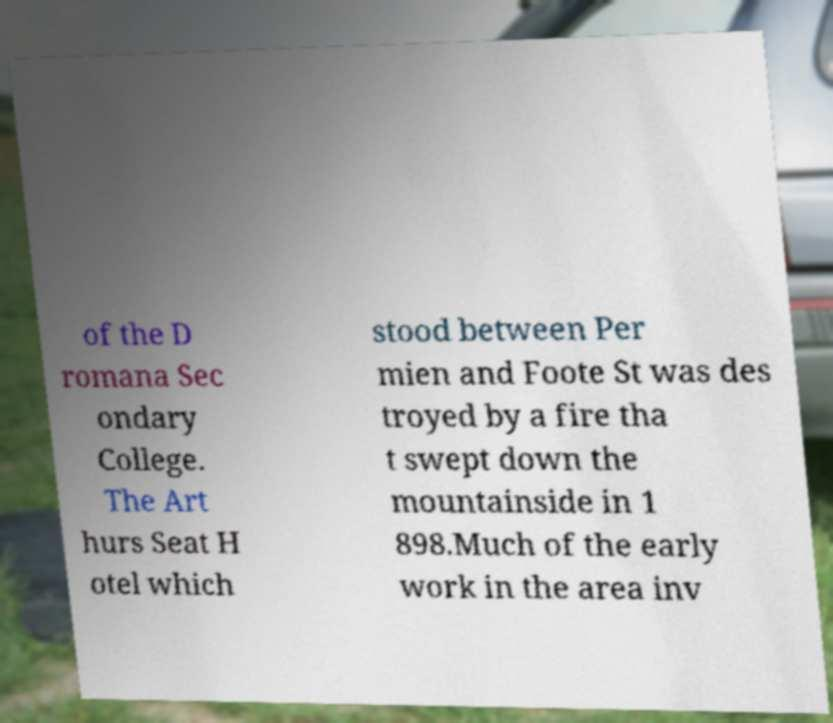Can you read and provide the text displayed in the image?This photo seems to have some interesting text. Can you extract and type it out for me? of the D romana Sec ondary College. The Art hurs Seat H otel which stood between Per mien and Foote St was des troyed by a fire tha t swept down the mountainside in 1 898.Much of the early work in the area inv 